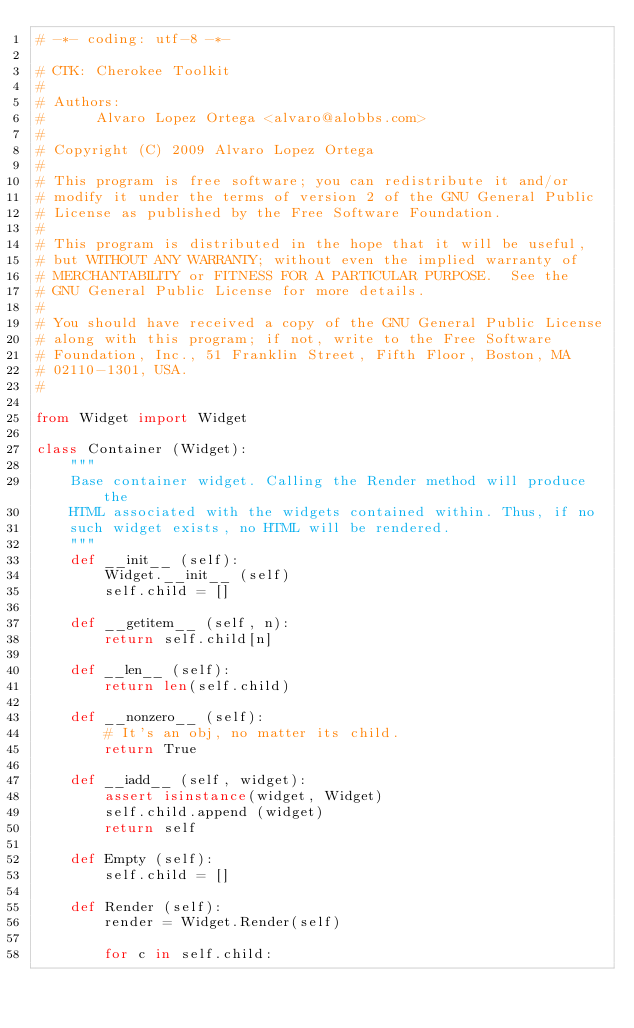<code> <loc_0><loc_0><loc_500><loc_500><_Python_># -*- coding: utf-8 -*-

# CTK: Cherokee Toolkit
#
# Authors:
#      Alvaro Lopez Ortega <alvaro@alobbs.com>
#
# Copyright (C) 2009 Alvaro Lopez Ortega
#
# This program is free software; you can redistribute it and/or
# modify it under the terms of version 2 of the GNU General Public
# License as published by the Free Software Foundation.
#
# This program is distributed in the hope that it will be useful,
# but WITHOUT ANY WARRANTY; without even the implied warranty of
# MERCHANTABILITY or FITNESS FOR A PARTICULAR PURPOSE.  See the
# GNU General Public License for more details.
#
# You should have received a copy of the GNU General Public License
# along with this program; if not, write to the Free Software
# Foundation, Inc., 51 Franklin Street, Fifth Floor, Boston, MA
# 02110-1301, USA.
#

from Widget import Widget

class Container (Widget):
    """
    Base container widget. Calling the Render method will produce the
    HTML associated with the widgets contained within. Thus, if no
    such widget exists, no HTML will be rendered.
    """
    def __init__ (self):
        Widget.__init__ (self)
        self.child = []

    def __getitem__ (self, n):
        return self.child[n]

    def __len__ (self):
        return len(self.child)

    def __nonzero__ (self):
        # It's an obj, no matter its child.
        return True

    def __iadd__ (self, widget):
        assert isinstance(widget, Widget)
        self.child.append (widget)
        return self

    def Empty (self):
        self.child = []

    def Render (self):
        render = Widget.Render(self)

        for c in self.child:</code> 